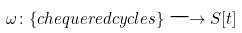Convert formula to latex. <formula><loc_0><loc_0><loc_500><loc_500>\omega \colon \{ c h e q u e r e d c y c l e s \} \longrightarrow S [ t ]</formula> 